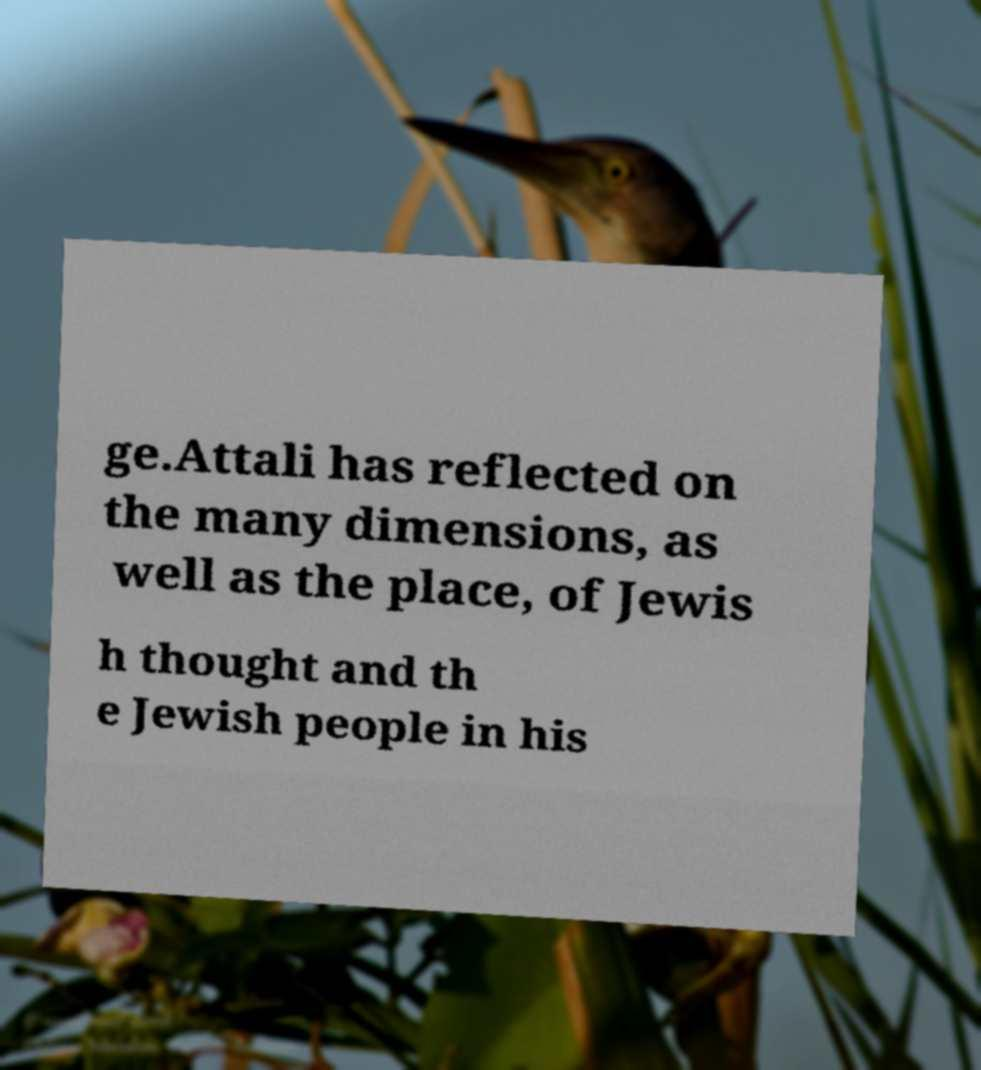I need the written content from this picture converted into text. Can you do that? ge.Attali has reflected on the many dimensions, as well as the place, of Jewis h thought and th e Jewish people in his 